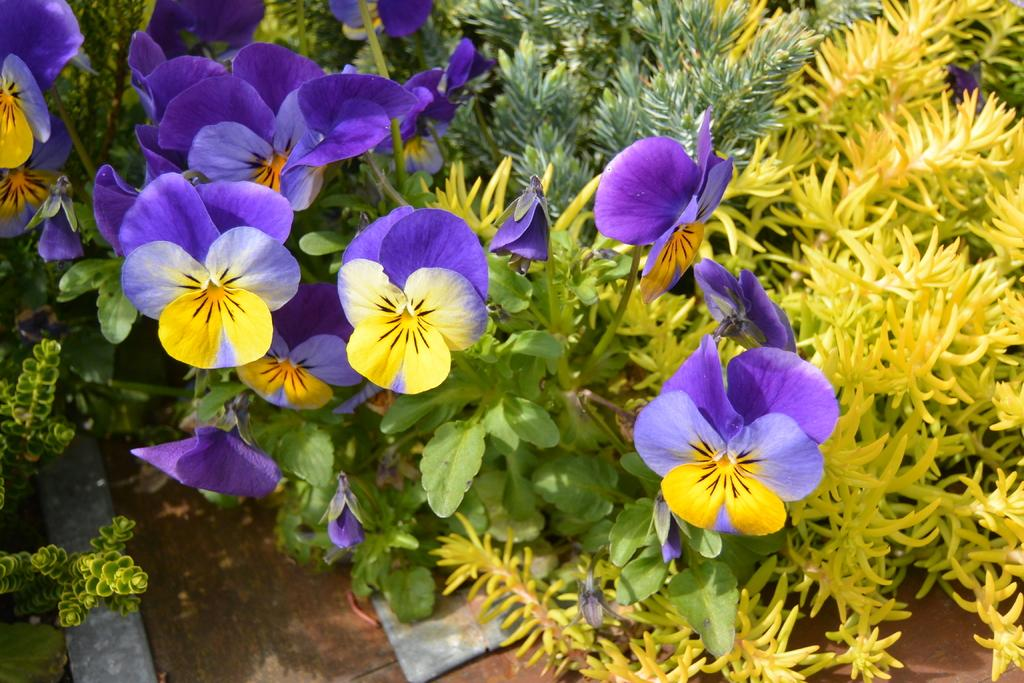What type of flora can be seen in the image? There are flowers in the image. What else is present in the image besides the flowers? The flowers are surrounded by various plants. What type of pest can be seen crawling on the flowers in the image? There is no pest visible on the flowers in the image. How does the presence of the flowers in the image make you feel? The presence of the flowers in the image does not evoke a specific emotion, as emotions are subjective and cannot be definitively determined from the image. 